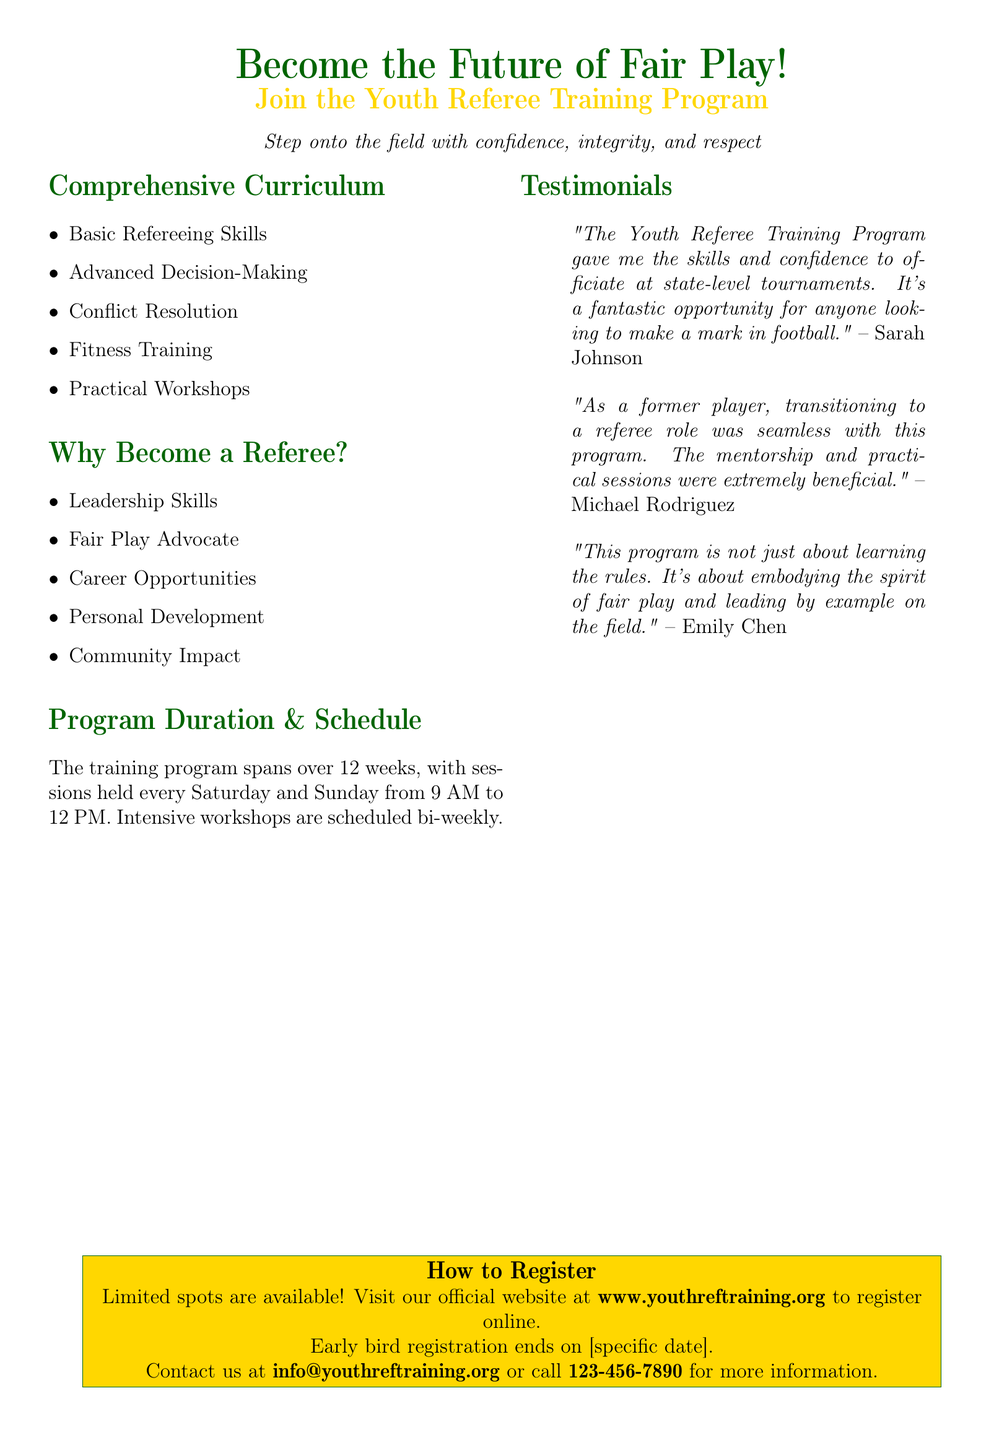What is the program duration? The program spans over 12 weeks with sessions on Saturdays and Sundays.
Answer: 12 weeks What is the website for registration? The document specifies the official website for registration.
Answer: www.youthreftraining.org What are the sessions held? The schedule includes sessions every Saturday and Sunday in the morning.
Answer: Saturday and Sunday Who is one of the successful referees mentioned? The document includes quotes from individuals who benefited from the program.
Answer: Sarah Johnson What is one of the benefits of becoming a referee? The document lists multiple benefits of becoming a referee.
Answer: Community Impact What time do the sessions start? The starting time for the training program sessions is specified in the document.
Answer: 9 AM What is the contact email for inquiries? The document provides a contact email for more information regarding registration.
Answer: info@youthreftraining.org What type of skills does the curriculum cover? The curriculum includes various skills related to refereeing.
Answer: Basic Refereeing Skills Why is the program described as an opportunity? The testimonials suggest how the program helps develop certain skills and opportunities.
Answer: Fantastic opportunity 